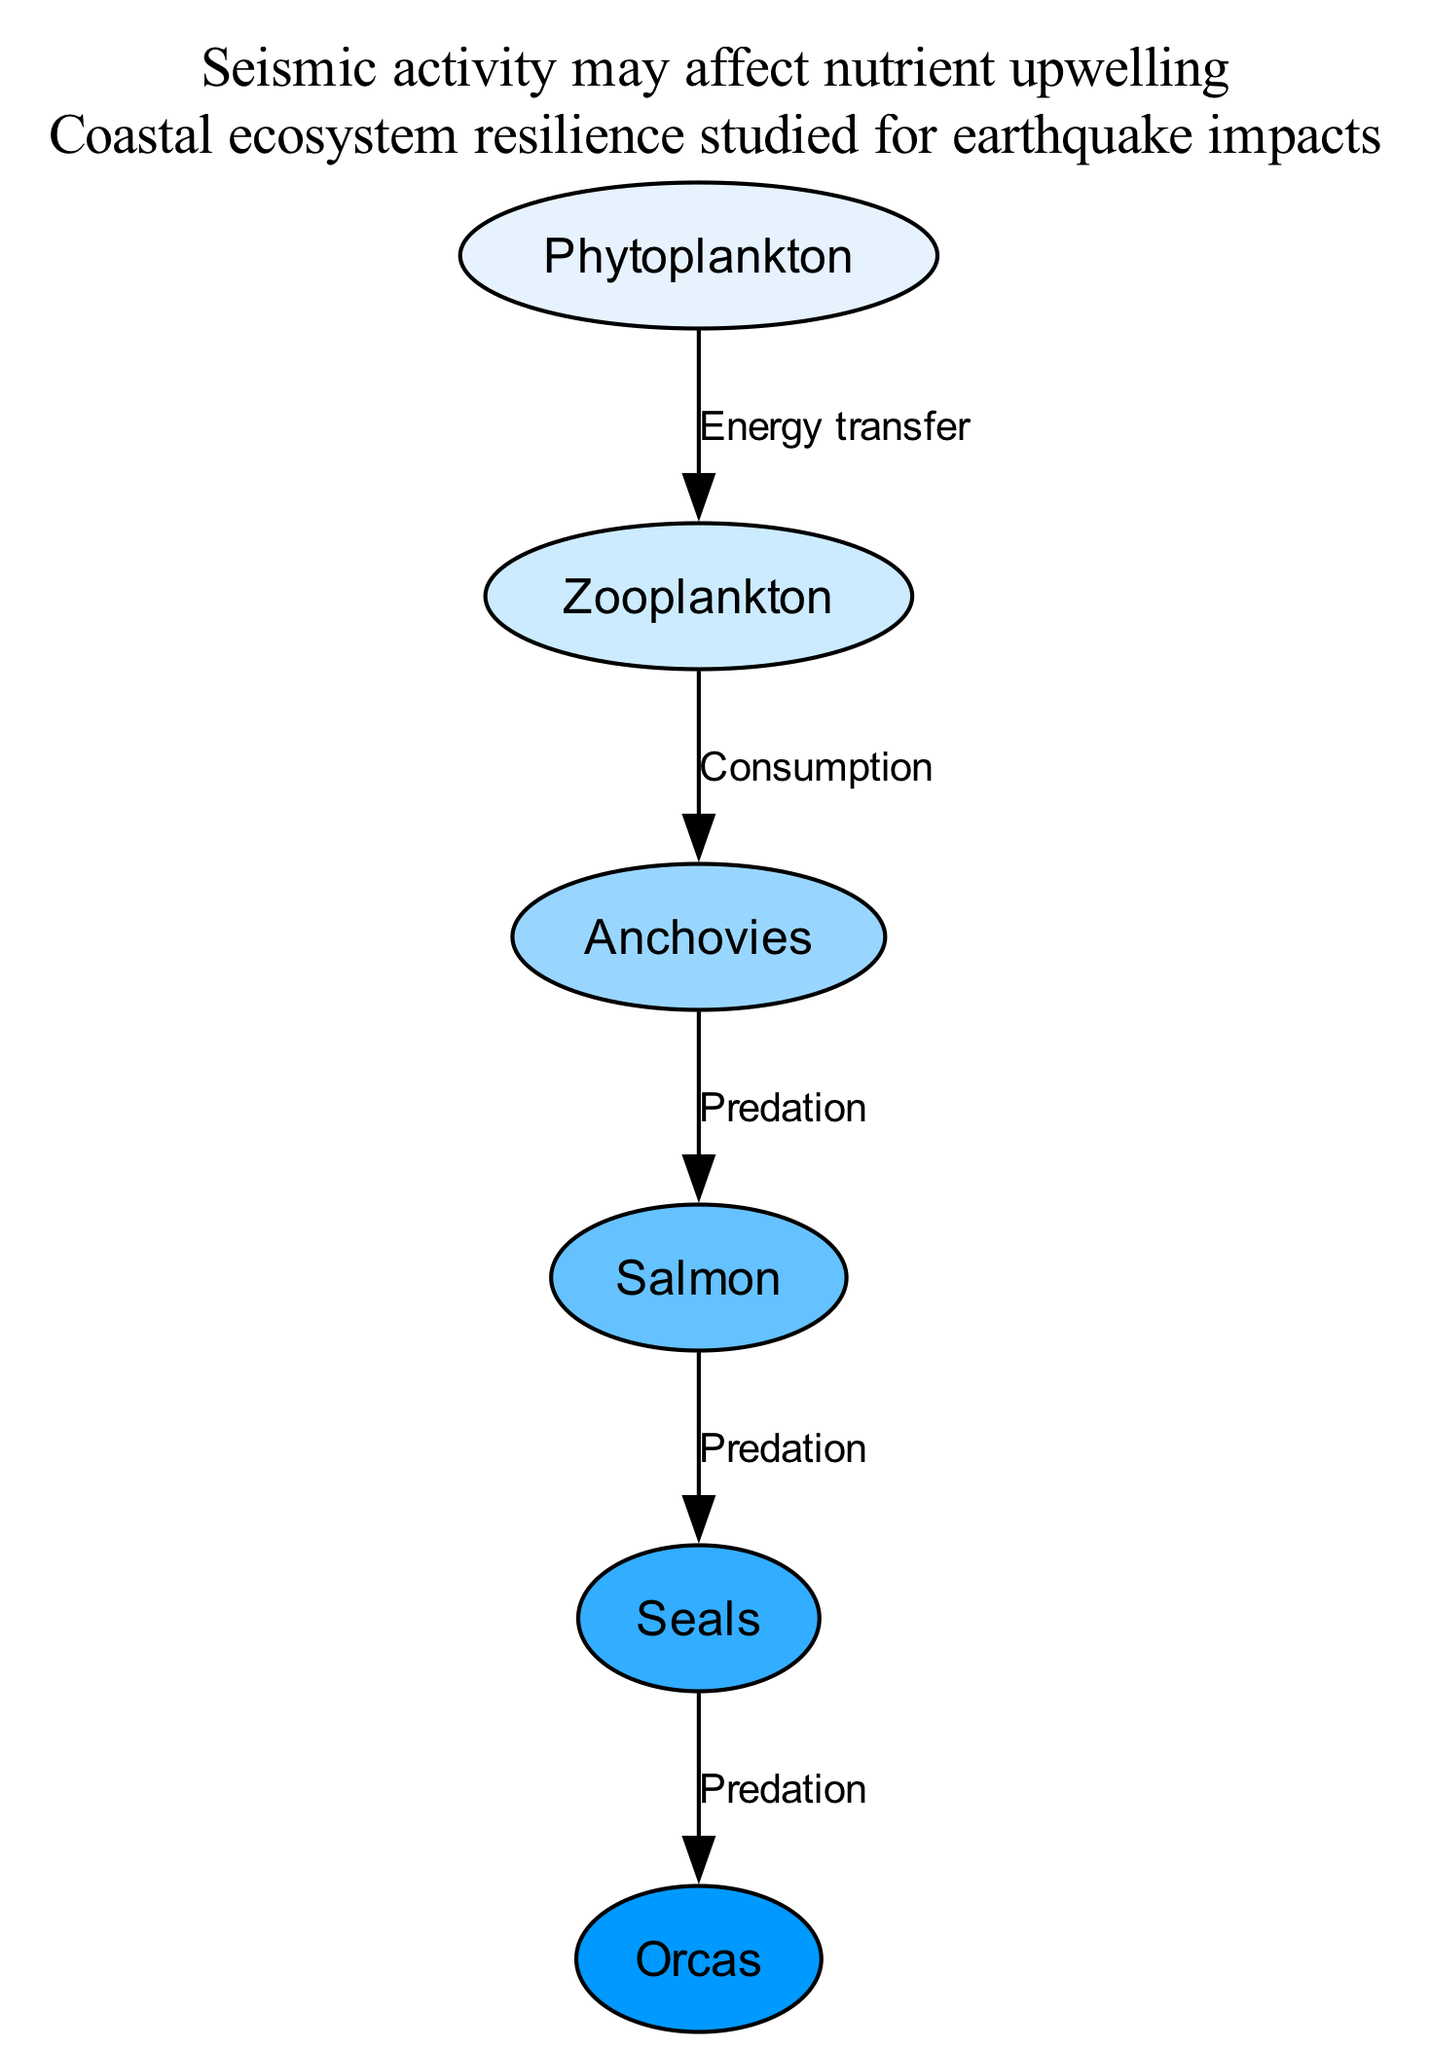What is the first trophic level in this food chain? The first trophic level in a food chain typically consists of primary producers, which are organisms that produce energy through photosynthesis. In this diagram, phytoplankton is the only node representing primary producers.
Answer: Phytoplankton How many consumption relationships are shown in the diagram? To find the number of consumption relationships, we count the edges labeled "Consumption" in the diagram. There is only one edge connecting zooplankton to anchovies labeled as "Consumption."
Answer: 1 Which organism is at the top of the food chain? The organism at the top of the food chain is known as the apex predator. In this diagram, the last node in the sequence of predation is orcas, making it the apex predator.
Answer: Orcas What is the relationship between anchovies and salmon? The relationship between anchovies and salmon is described as "Predation," indicating that salmon prey on anchovies. This is depicted by the directed edge from anchovies to salmon labeled "Predation."
Answer: Predation If seals are removed from the ecosystem, who would be directly affected according to the diagram? The removal of seals, which are predatory to orcas, would directly affect orcas since they rely on seals as a food source. In the diagram, the edge from seals to orcas represents this predatory relationship.
Answer: Orcas How many total nodes are depicted in the diagram? The total number of nodes is calculated by counting each unique organism represented in the diagram. There are six distinct organisms listed as nodes, namely phytoplankton, zooplankton, anchovies, salmon, seals, and orcas.
Answer: 6 What impact might seismic activity have in this ecosystem according to the annotations? The diagram includes an annotation stating, "Seismic activity may affect nutrient upwelling". This suggests that seismic activity could disrupt the availability of nutrients crucial for primary production, particularly impacting organisms like phytoplankton.
Answer: Nutrient upwelling 